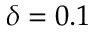Convert formula to latex. <formula><loc_0><loc_0><loc_500><loc_500>\delta = 0 . 1</formula> 